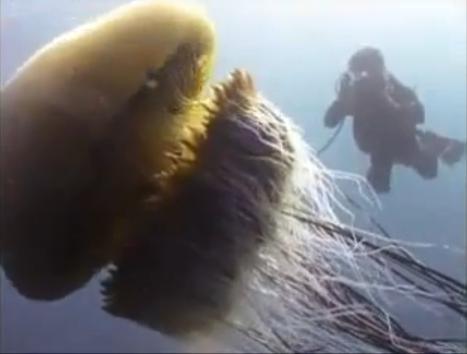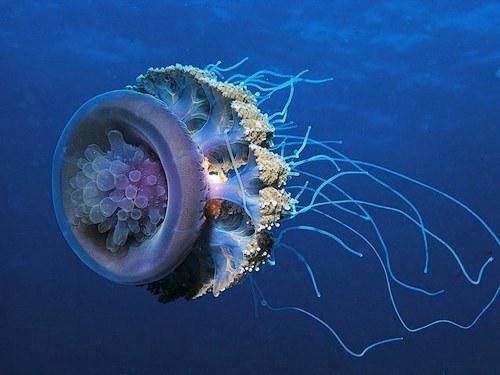The first image is the image on the left, the second image is the image on the right. Examine the images to the left and right. Is the description "One image shows exactly one peachy colored jellyfish, and no scuba diver present." accurate? Answer yes or no. No. 